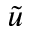<formula> <loc_0><loc_0><loc_500><loc_500>\tilde { u }</formula> 